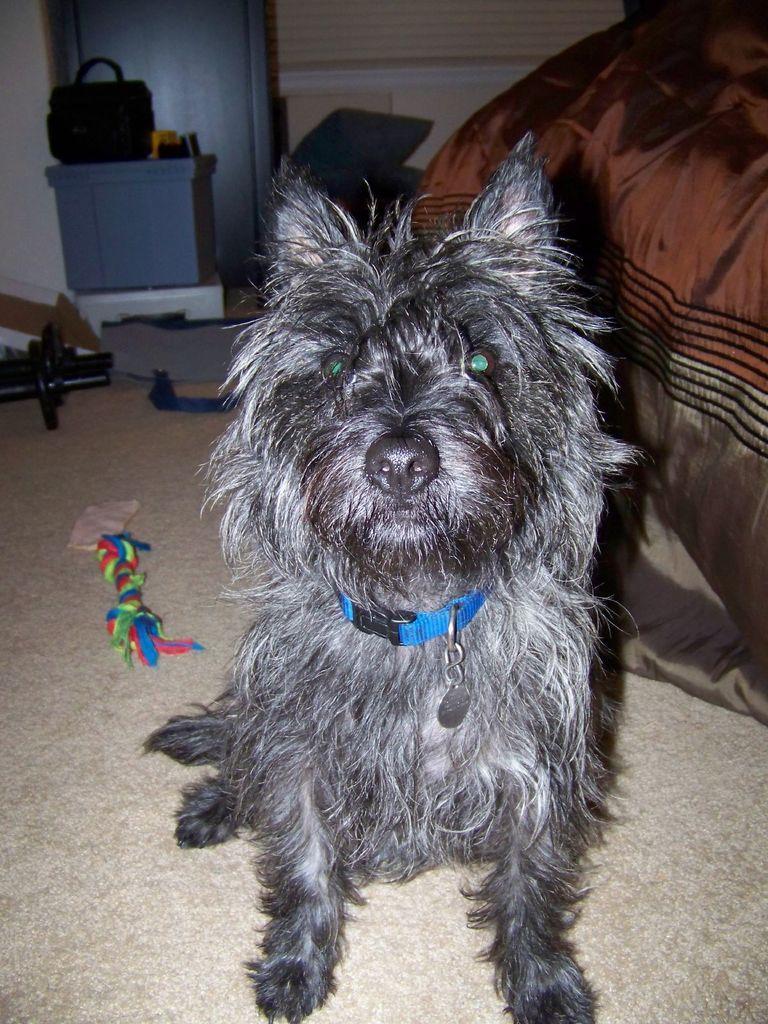Could you give a brief overview of what you see in this image? On floor there is a dog. Beside this dog there is a bed. Far there is a container. Above this container there is a bag. 